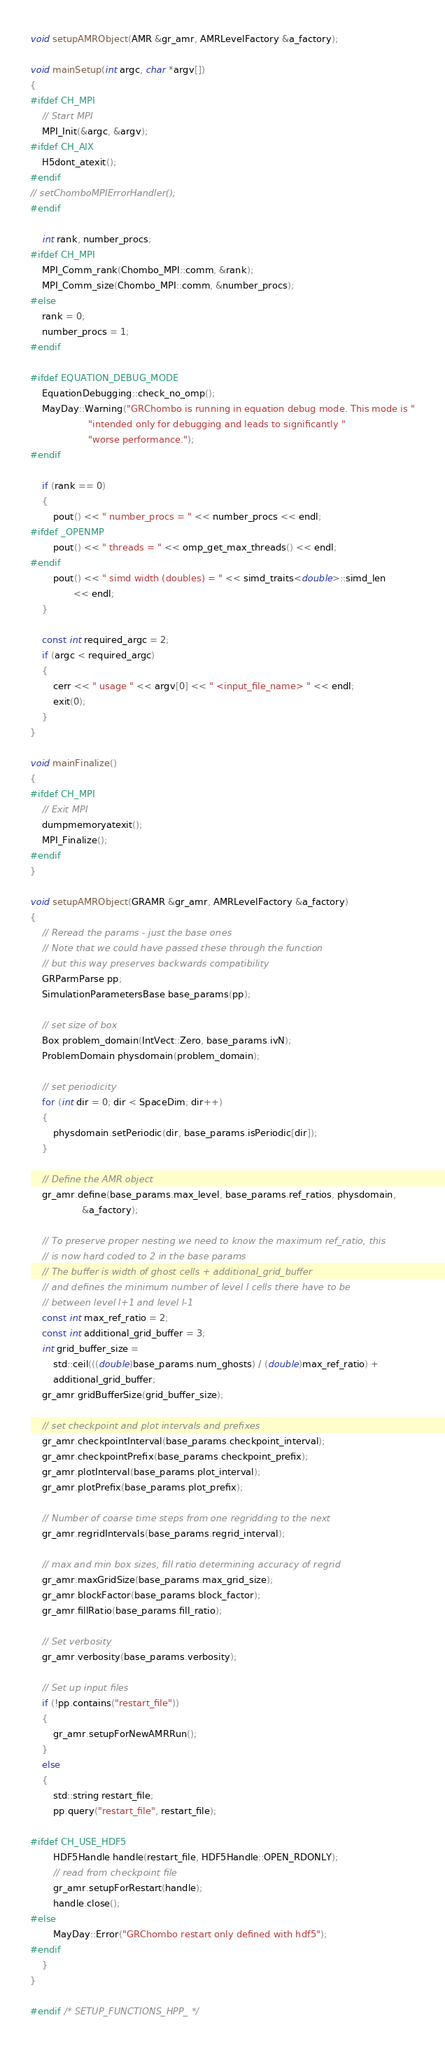Convert code to text. <code><loc_0><loc_0><loc_500><loc_500><_C++_>void setupAMRObject(AMR &gr_amr, AMRLevelFactory &a_factory);

void mainSetup(int argc, char *argv[])
{
#ifdef CH_MPI
    // Start MPI
    MPI_Init(&argc, &argv);
#ifdef CH_AIX
    H5dont_atexit();
#endif
// setChomboMPIErrorHandler();
#endif

    int rank, number_procs;
#ifdef CH_MPI
    MPI_Comm_rank(Chombo_MPI::comm, &rank);
    MPI_Comm_size(Chombo_MPI::comm, &number_procs);
#else
    rank = 0;
    number_procs = 1;
#endif

#ifdef EQUATION_DEBUG_MODE
    EquationDebugging::check_no_omp();
    MayDay::Warning("GRChombo is running in equation debug mode. This mode is "
                    "intended only for debugging and leads to significantly "
                    "worse performance.");
#endif

    if (rank == 0)
    {
        pout() << " number_procs = " << number_procs << endl;
#ifdef _OPENMP
        pout() << " threads = " << omp_get_max_threads() << endl;
#endif
        pout() << " simd width (doubles) = " << simd_traits<double>::simd_len
               << endl;
    }

    const int required_argc = 2;
    if (argc < required_argc)
    {
        cerr << " usage " << argv[0] << " <input_file_name> " << endl;
        exit(0);
    }
}

void mainFinalize()
{
#ifdef CH_MPI
    // Exit MPI
    dumpmemoryatexit();
    MPI_Finalize();
#endif
}

void setupAMRObject(GRAMR &gr_amr, AMRLevelFactory &a_factory)
{
    // Reread the params - just the base ones
    // Note that we could have passed these through the function
    // but this way preserves backwards compatibility
    GRParmParse pp;
    SimulationParametersBase base_params(pp);

    // set size of box
    Box problem_domain(IntVect::Zero, base_params.ivN);
    ProblemDomain physdomain(problem_domain);

    // set periodicity
    for (int dir = 0; dir < SpaceDim; dir++)
    {
        physdomain.setPeriodic(dir, base_params.isPeriodic[dir]);
    }

    // Define the AMR object
    gr_amr.define(base_params.max_level, base_params.ref_ratios, physdomain,
                  &a_factory);

    // To preserve proper nesting we need to know the maximum ref_ratio, this
    // is now hard coded to 2 in the base params
    // The buffer is width of ghost cells + additional_grid_buffer
    // and defines the minimum number of level l cells there have to be
    // between level l+1 and level l-1
    const int max_ref_ratio = 2;
    const int additional_grid_buffer = 3;
    int grid_buffer_size =
        std::ceil(((double)base_params.num_ghosts) / (double)max_ref_ratio) +
        additional_grid_buffer;
    gr_amr.gridBufferSize(grid_buffer_size);

    // set checkpoint and plot intervals and prefixes
    gr_amr.checkpointInterval(base_params.checkpoint_interval);
    gr_amr.checkpointPrefix(base_params.checkpoint_prefix);
    gr_amr.plotInterval(base_params.plot_interval);
    gr_amr.plotPrefix(base_params.plot_prefix);

    // Number of coarse time steps from one regridding to the next
    gr_amr.regridIntervals(base_params.regrid_interval);

    // max and min box sizes, fill ratio determining accuracy of regrid
    gr_amr.maxGridSize(base_params.max_grid_size);
    gr_amr.blockFactor(base_params.block_factor);
    gr_amr.fillRatio(base_params.fill_ratio);

    // Set verbosity
    gr_amr.verbosity(base_params.verbosity);

    // Set up input files
    if (!pp.contains("restart_file"))
    {
        gr_amr.setupForNewAMRRun();
    }
    else
    {
        std::string restart_file;
        pp.query("restart_file", restart_file);

#ifdef CH_USE_HDF5
        HDF5Handle handle(restart_file, HDF5Handle::OPEN_RDONLY);
        // read from checkpoint file
        gr_amr.setupForRestart(handle);
        handle.close();
#else
        MayDay::Error("GRChombo restart only defined with hdf5");
#endif
    }
}

#endif /* SETUP_FUNCTIONS_HPP_ */
</code> 